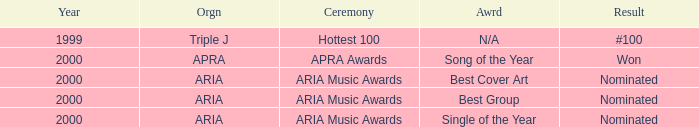What's the award for #100? N/A. 